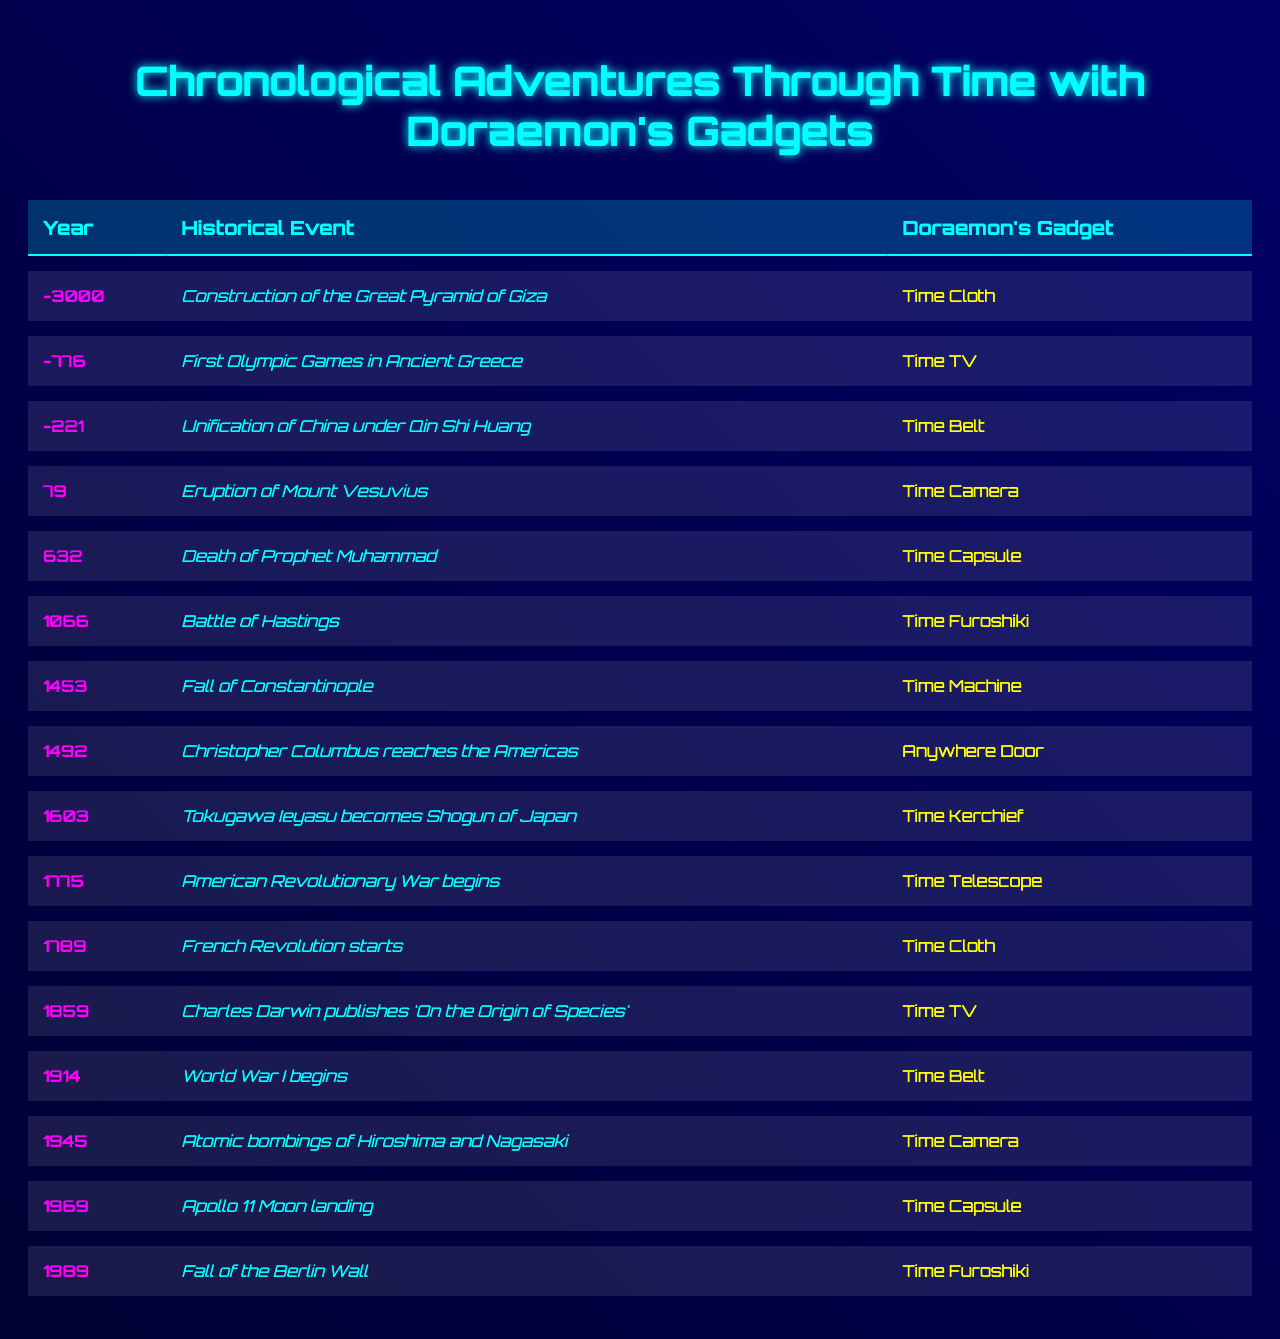What historical event occurred in the year 1492? The table lists "Christopher Columbus reaches the Americas" as the event in the year 1492.
Answer: Christopher Columbus reaches the Americas Which gadget was used during the Battle of Hastings in 1066? The table shows that "Time Furoshiki" was the gadget used during the Battle of Hastings, which took place in 1066.
Answer: Time Furoshiki How many events are recorded that took place in the 19th century? The events from the table that fall within the 19th century (1801-1900) are: "Charles Darwin publishes 'On the Origin of Species'" in 1859, which makes a total of 1 event.
Answer: 1 What was the gadget used for the atomic bombings of Hiroshima and Nagasaki in 1945? According to the table, the gadget used for the atomic bombings of Hiroshima and Nagasaki in 1945 was the "Time Camera."
Answer: Time Camera Did any events occur in the 1st century? The table shows that there was an event, "Eruption of Mount Vesuvius," that occurred in the year 79, which confirms that there was an event in the 1st century.
Answer: Yes Which event occurred first: the French Revolution or the American Revolutionary War? By checking the years, the American Revolutionary War began in 1775 and the French Revolution started in 1789, indicating that the American Revolutionary War occurred first.
Answer: American Revolutionary War What is the most recent historical event listed in the table? Reviewing the table, the most recent event is the "Fall of the Berlin Wall," which occurred in 1989.
Answer: Fall of the Berlin Wall Which gadget was used twice in the events recorded? The table indicates that "Time Cloth" and "Time Camera" were both used in two different events, specifically in the years -3000 and 1789 for "Time Cloth," and in 79 and 1945 for "Time Camera."
Answer: Time Cloth and Time Camera How many events occurred before the year 1000? From the table, the events before the year 1000 are: the Great Pyramid of Giza in -3000, the First Olympic Games in -776, and the Unification of China in -221; therefore, a total of 3 events occurred before the year 1000.
Answer: 3 What is the difference in years between the event with the earliest date and the latest date? The earliest event is from -3000 (Great Pyramid of Giza) and the latest is from 1989 (Fall of the Berlin Wall). The difference is calculated as 1989 - (-3000) = 1989 + 3000 = 4989 years.
Answer: 4989 years 